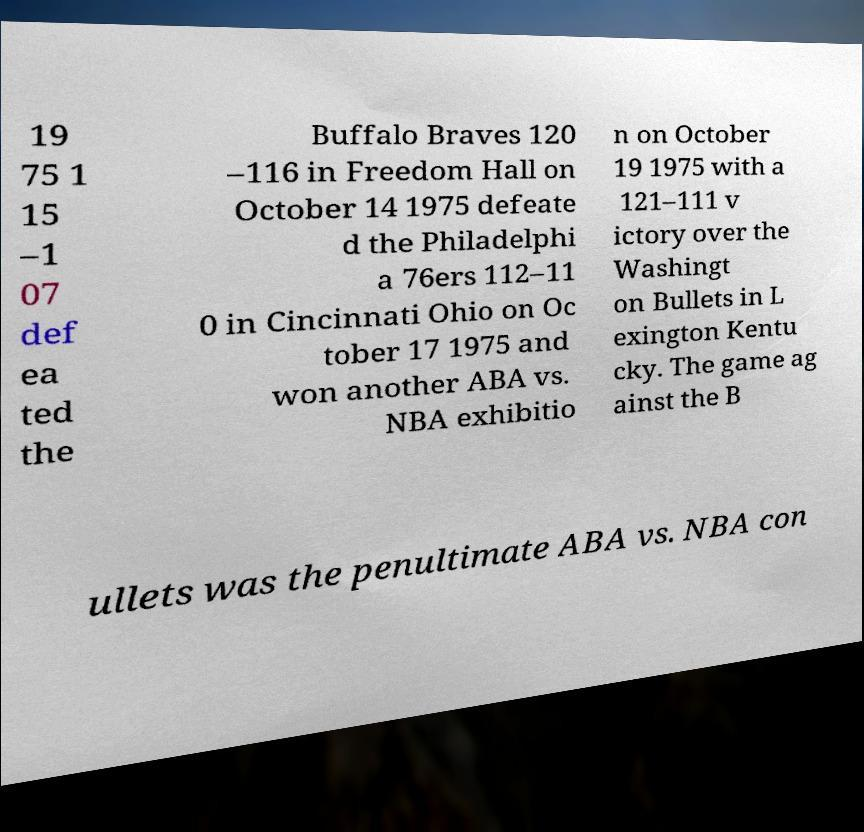Can you accurately transcribe the text from the provided image for me? 19 75 1 15 –1 07 def ea ted the Buffalo Braves 120 –116 in Freedom Hall on October 14 1975 defeate d the Philadelphi a 76ers 112–11 0 in Cincinnati Ohio on Oc tober 17 1975 and won another ABA vs. NBA exhibitio n on October 19 1975 with a 121–111 v ictory over the Washingt on Bullets in L exington Kentu cky. The game ag ainst the B ullets was the penultimate ABA vs. NBA con 